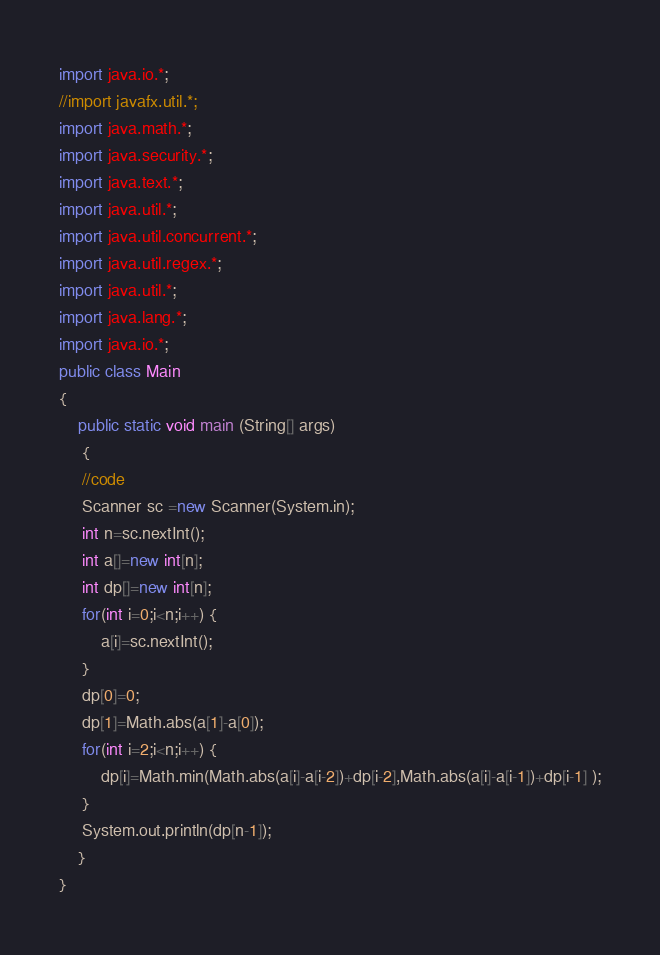<code> <loc_0><loc_0><loc_500><loc_500><_Java_>import java.io.*;
//import javafx.util.*;
import java.math.*;
import java.security.*;
import java.text.*;
import java.util.*;
import java.util.concurrent.*;
import java.util.regex.*;
import java.util.*;
import java.lang.*;
import java.io.*;
public class Main
{
	public static void main (String[] args)
	 {
	 //code
	 Scanner sc =new Scanner(System.in);
	 int n=sc.nextInt();
	 int a[]=new int[n];
	 int dp[]=new int[n];
	 for(int i=0;i<n;i++) {
		 a[i]=sc.nextInt();
	 }
	 dp[0]=0;
	 dp[1]=Math.abs(a[1]-a[0]);
	 for(int i=2;i<n;i++) {
		 dp[i]=Math.min(Math.abs(a[i]-a[i-2])+dp[i-2],Math.abs(a[i]-a[i-1])+dp[i-1] );
	 }
	 System.out.println(dp[n-1]);
	}
}</code> 